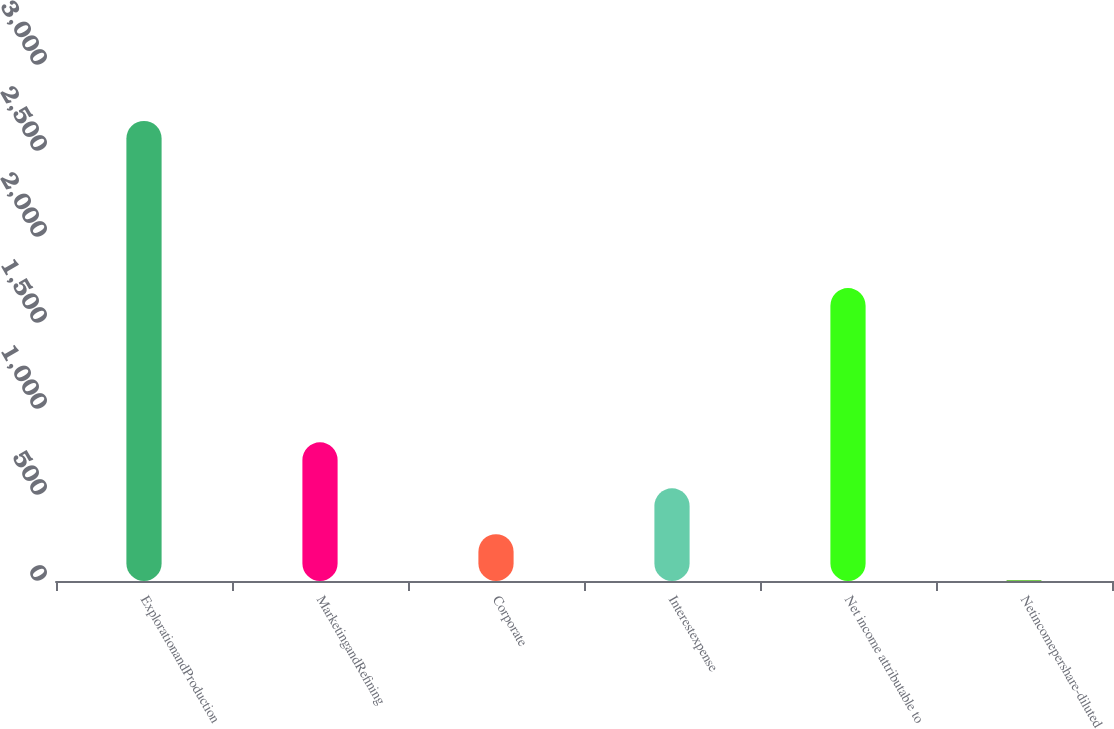<chart> <loc_0><loc_0><loc_500><loc_500><bar_chart><fcel>ExplorationandProduction<fcel>MarketingandRefining<fcel>Corporate<fcel>Interestexpense<fcel>Net income attributable to<fcel>Netincomepershare-diluted<nl><fcel>2675<fcel>806.01<fcel>272.01<fcel>539.01<fcel>1703<fcel>5.01<nl></chart> 